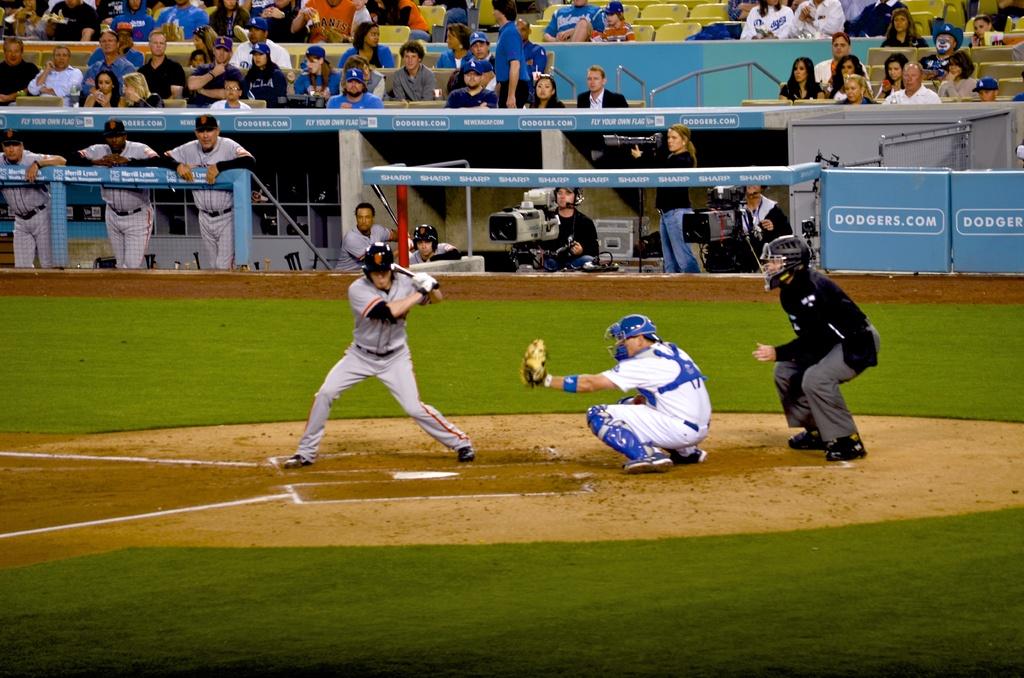Who is playing the game?
Offer a terse response. Dodgers. 